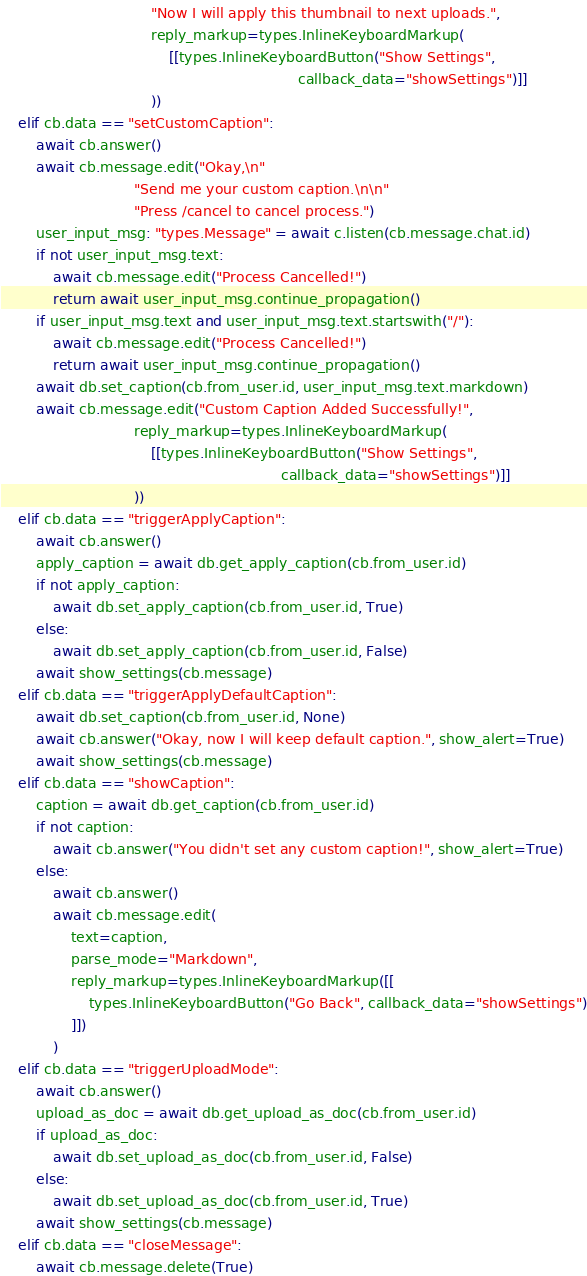<code> <loc_0><loc_0><loc_500><loc_500><_Python_>                                  "Now I will apply this thumbnail to next uploads.",
                                  reply_markup=types.InlineKeyboardMarkup(
                                      [[types.InlineKeyboardButton("Show Settings",
                                                                   callback_data="showSettings")]]
                                  ))
    elif cb.data == "setCustomCaption":
        await cb.answer()
        await cb.message.edit("Okay,\n"
                              "Send me your custom caption.\n\n"
                              "Press /cancel to cancel process.")
        user_input_msg: "types.Message" = await c.listen(cb.message.chat.id)
        if not user_input_msg.text:
            await cb.message.edit("Process Cancelled!")
            return await user_input_msg.continue_propagation()
        if user_input_msg.text and user_input_msg.text.startswith("/"):
            await cb.message.edit("Process Cancelled!")
            return await user_input_msg.continue_propagation()
        await db.set_caption(cb.from_user.id, user_input_msg.text.markdown)
        await cb.message.edit("Custom Caption Added Successfully!",
                              reply_markup=types.InlineKeyboardMarkup(
                                  [[types.InlineKeyboardButton("Show Settings",
                                                               callback_data="showSettings")]]
                              ))
    elif cb.data == "triggerApplyCaption":
        await cb.answer()
        apply_caption = await db.get_apply_caption(cb.from_user.id)
        if not apply_caption:
            await db.set_apply_caption(cb.from_user.id, True)
        else:
            await db.set_apply_caption(cb.from_user.id, False)
        await show_settings(cb.message)
    elif cb.data == "triggerApplyDefaultCaption":
        await db.set_caption(cb.from_user.id, None)
        await cb.answer("Okay, now I will keep default caption.", show_alert=True)
        await show_settings(cb.message)
    elif cb.data == "showCaption":
        caption = await db.get_caption(cb.from_user.id)
        if not caption:
            await cb.answer("You didn't set any custom caption!", show_alert=True)
        else:
            await cb.answer()
            await cb.message.edit(
                text=caption,
                parse_mode="Markdown",
                reply_markup=types.InlineKeyboardMarkup([[
                    types.InlineKeyboardButton("Go Back", callback_data="showSettings")
                ]])
            )
    elif cb.data == "triggerUploadMode":
        await cb.answer()
        upload_as_doc = await db.get_upload_as_doc(cb.from_user.id)
        if upload_as_doc:
            await db.set_upload_as_doc(cb.from_user.id, False)
        else:
            await db.set_upload_as_doc(cb.from_user.id, True)
        await show_settings(cb.message)
    elif cb.data == "closeMessage":
        await cb.message.delete(True)
</code> 